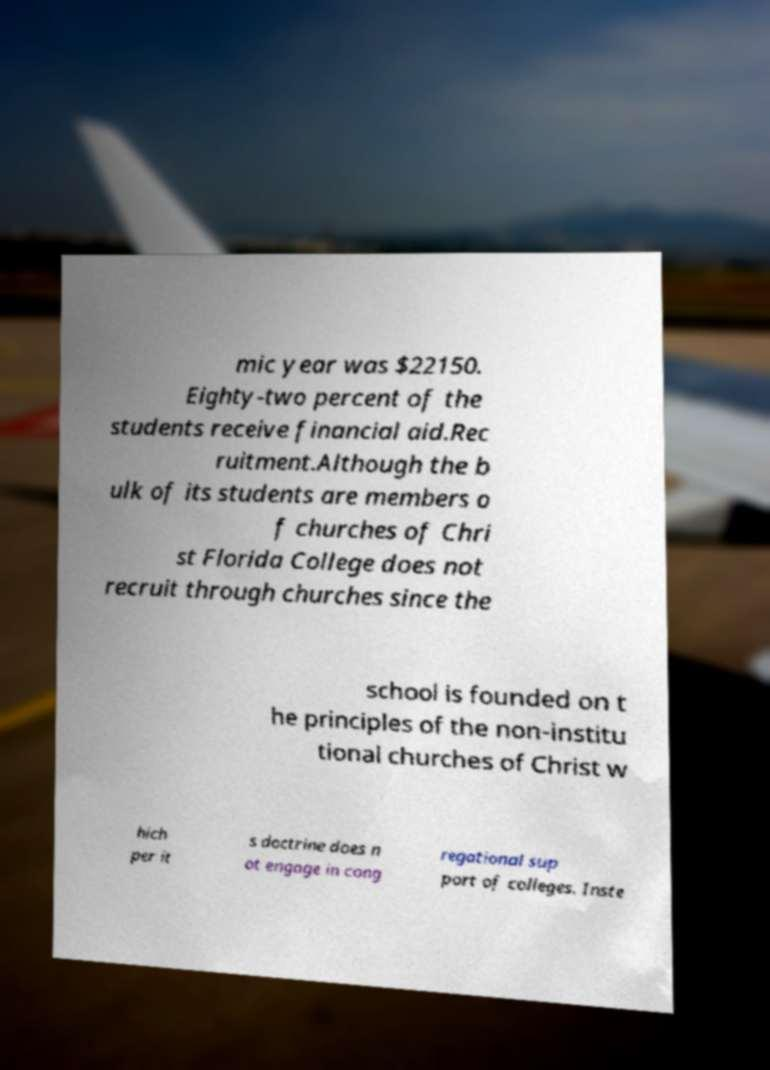Could you assist in decoding the text presented in this image and type it out clearly? mic year was $22150. Eighty-two percent of the students receive financial aid.Rec ruitment.Although the b ulk of its students are members o f churches of Chri st Florida College does not recruit through churches since the school is founded on t he principles of the non-institu tional churches of Christ w hich per it s doctrine does n ot engage in cong regational sup port of colleges. Inste 